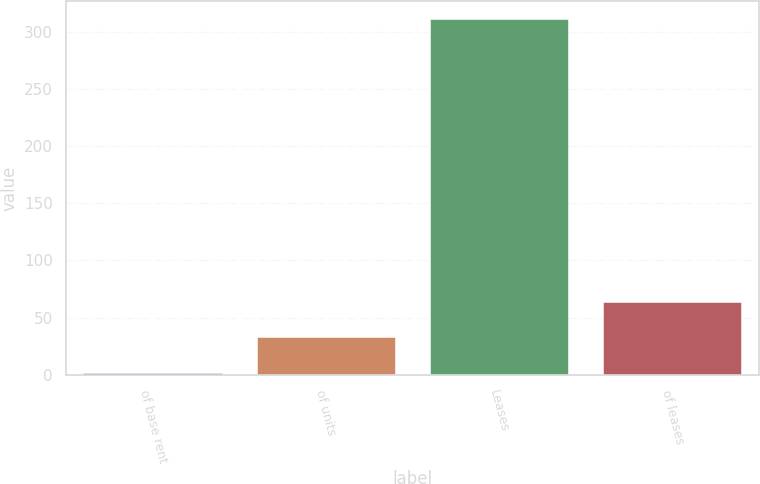Convert chart to OTSL. <chart><loc_0><loc_0><loc_500><loc_500><bar_chart><fcel>of base rent<fcel>of units<fcel>Leases<fcel>of leases<nl><fcel>2<fcel>32.9<fcel>311<fcel>63.8<nl></chart> 